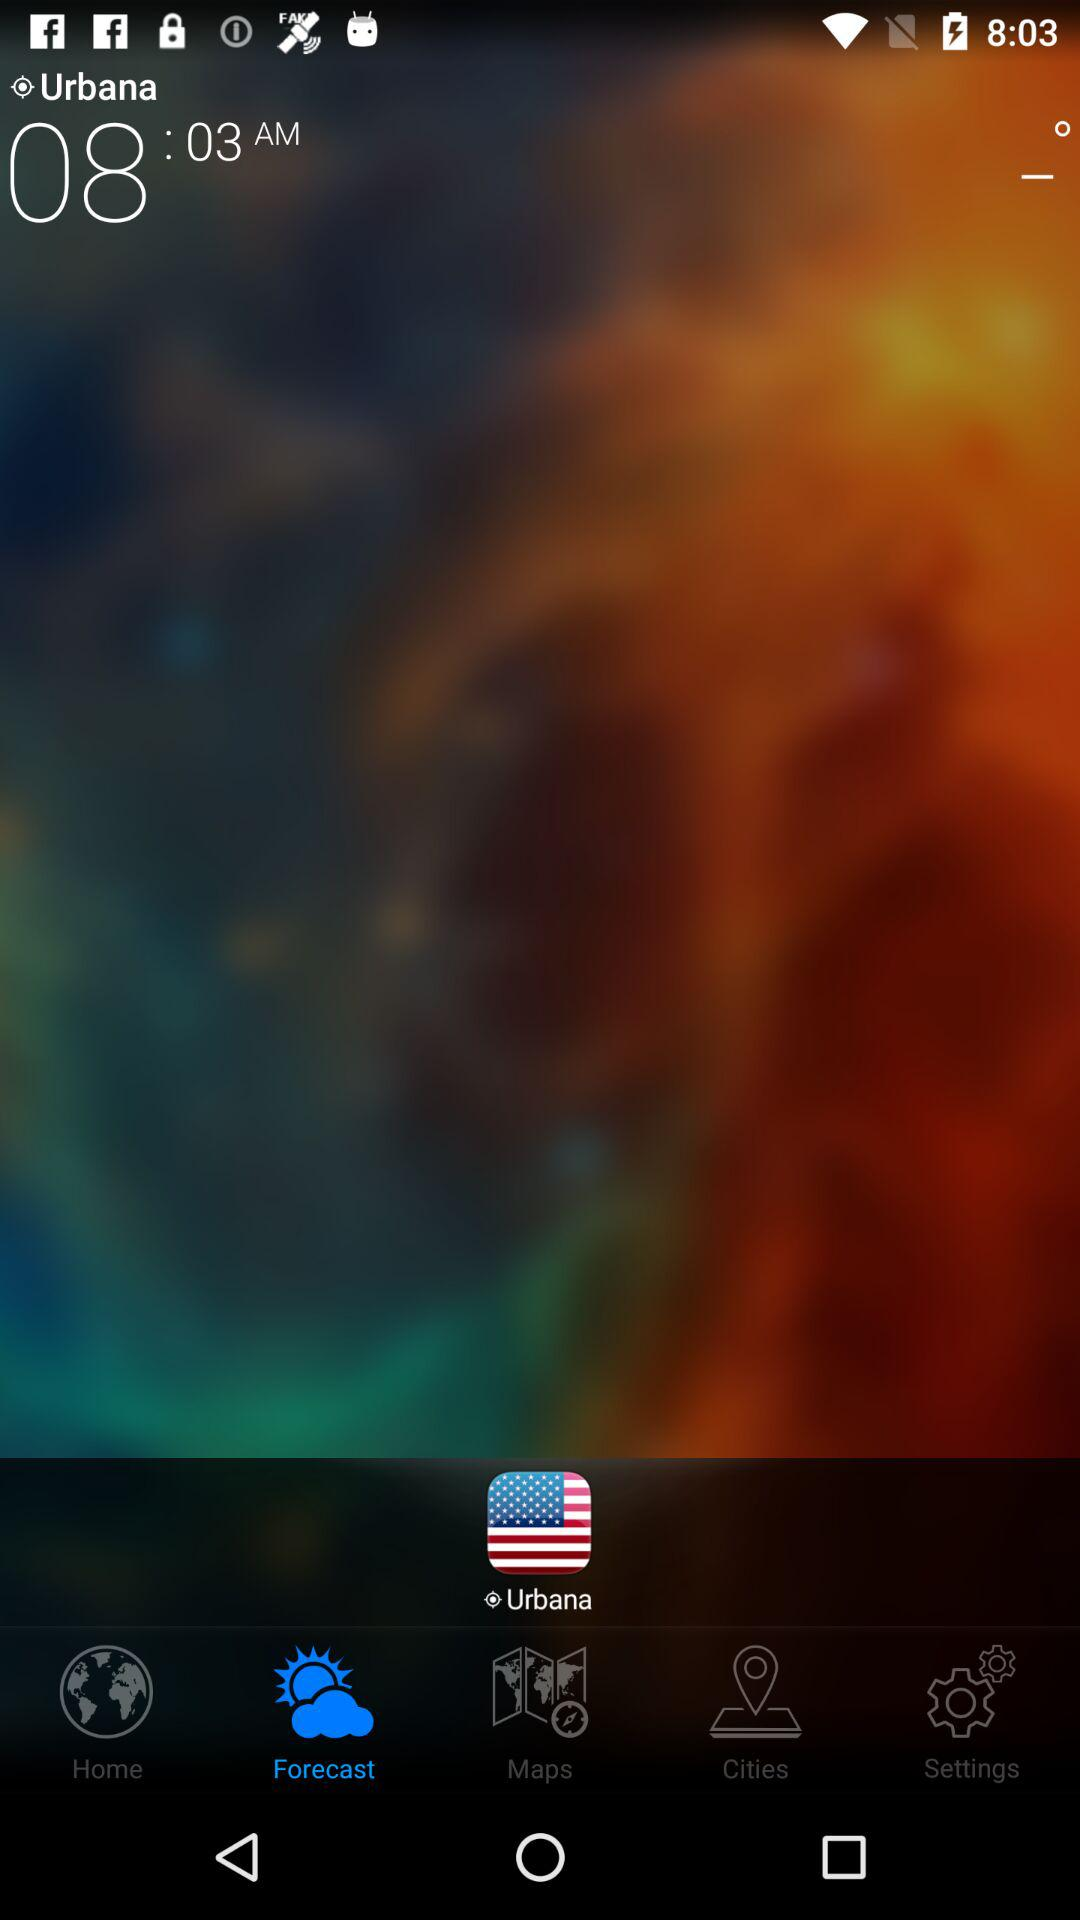Which tab is currently selected? The currently selected tab is "Forecast". 